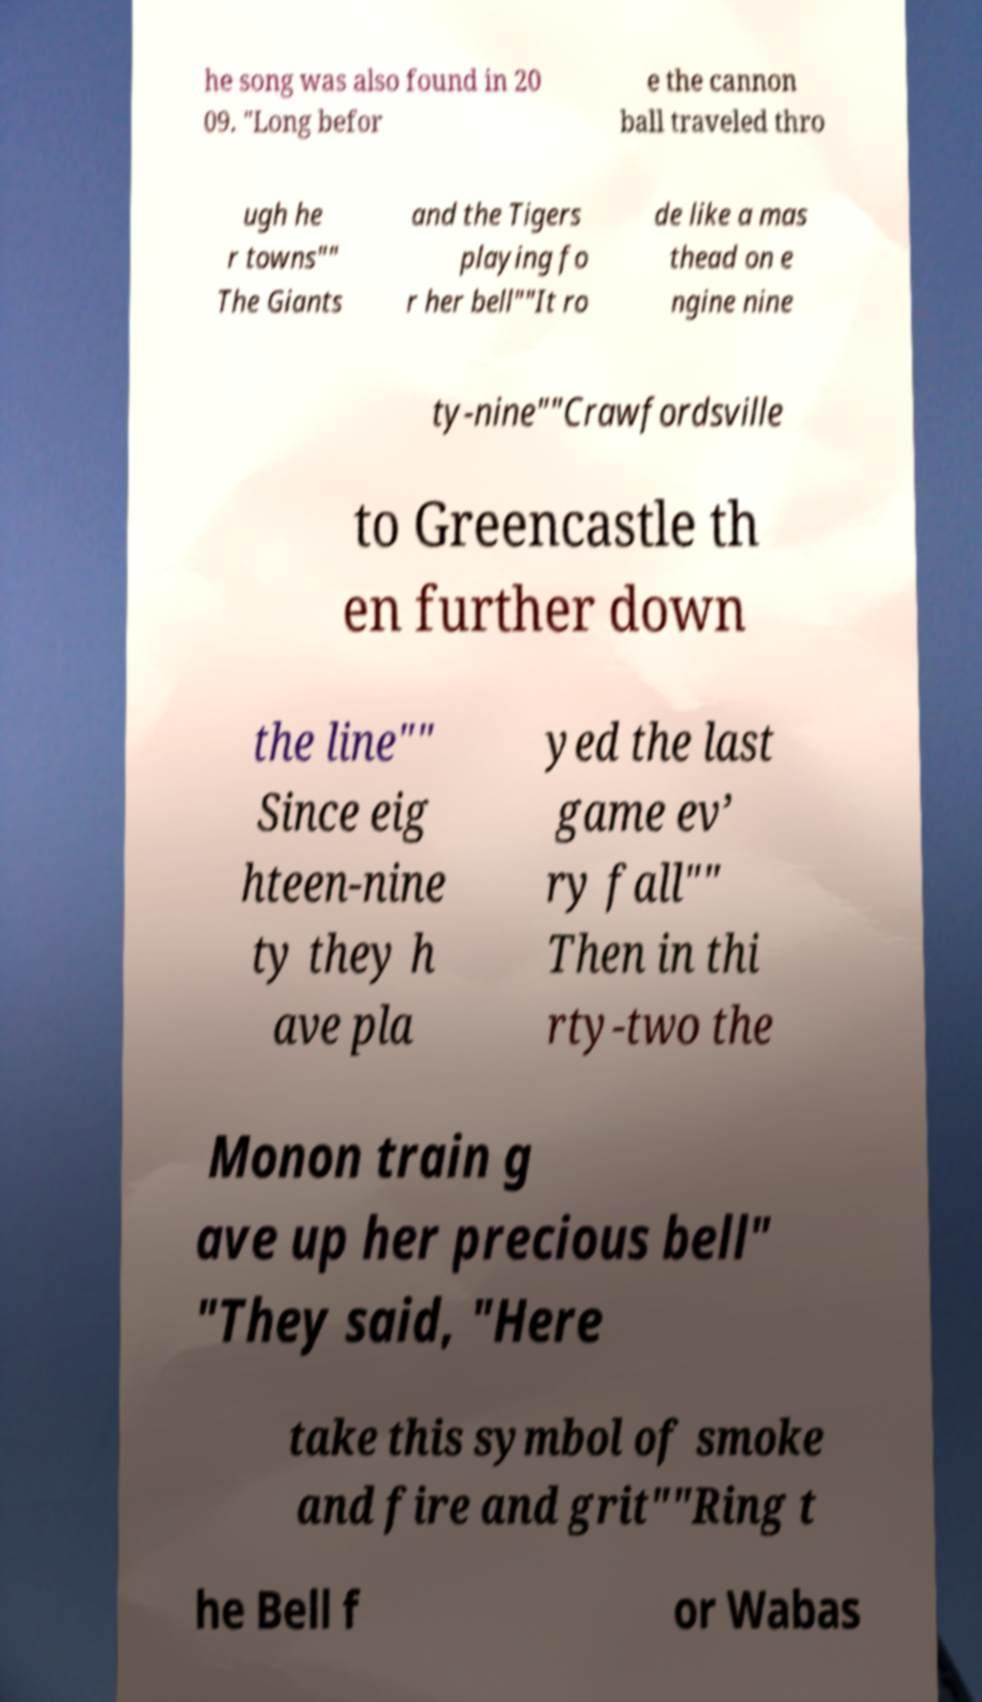Can you accurately transcribe the text from the provided image for me? he song was also found in 20 09. "Long befor e the cannon ball traveled thro ugh he r towns"" The Giants and the Tigers playing fo r her bell""It ro de like a mas thead on e ngine nine ty-nine""Crawfordsville to Greencastle th en further down the line"" Since eig hteen-nine ty they h ave pla yed the last game ev’ ry fall"" Then in thi rty-two the Monon train g ave up her precious bell" "They said, "Here take this symbol of smoke and fire and grit""Ring t he Bell f or Wabas 